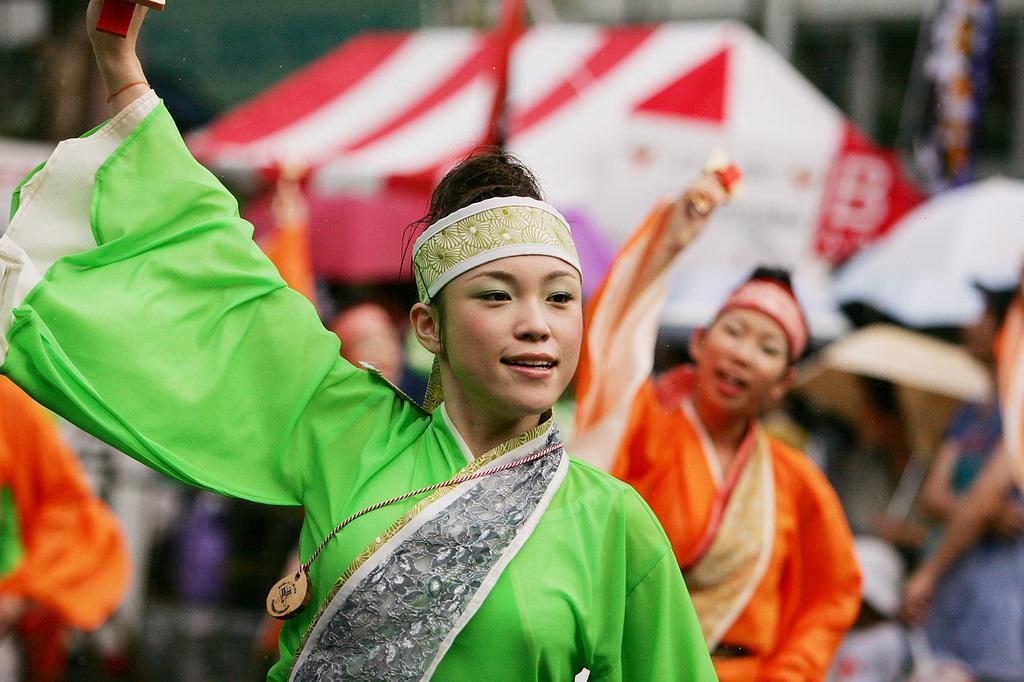Please provide a concise description of this image. In this image there are few persons dancing. Behind them there are few tents. Right side there are few persons standing. 